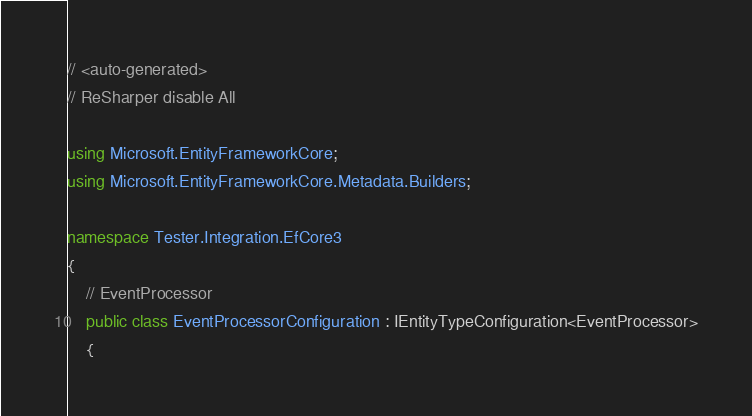<code> <loc_0><loc_0><loc_500><loc_500><_C#_>// <auto-generated>
// ReSharper disable All

using Microsoft.EntityFrameworkCore;
using Microsoft.EntityFrameworkCore.Metadata.Builders;

namespace Tester.Integration.EfCore3
{
    // EventProcessor
    public class EventProcessorConfiguration : IEntityTypeConfiguration<EventProcessor>
    {</code> 